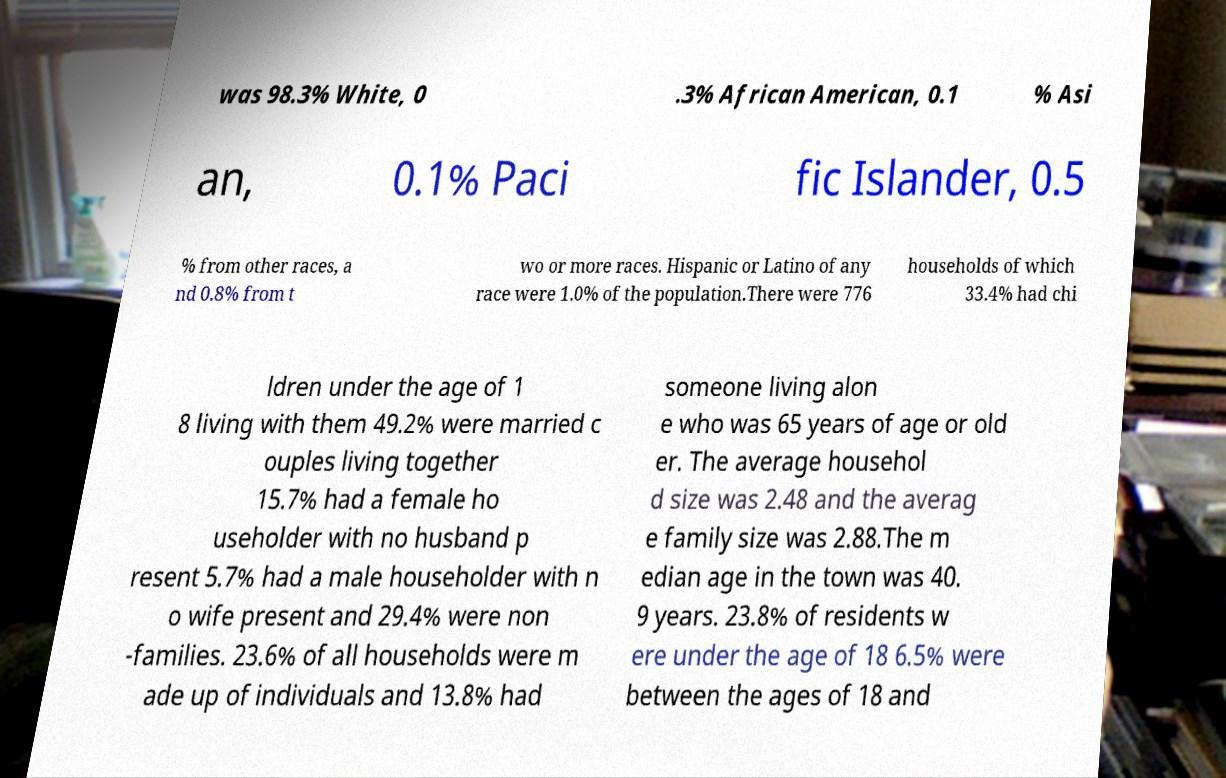I need the written content from this picture converted into text. Can you do that? was 98.3% White, 0 .3% African American, 0.1 % Asi an, 0.1% Paci fic Islander, 0.5 % from other races, a nd 0.8% from t wo or more races. Hispanic or Latino of any race were 1.0% of the population.There were 776 households of which 33.4% had chi ldren under the age of 1 8 living with them 49.2% were married c ouples living together 15.7% had a female ho useholder with no husband p resent 5.7% had a male householder with n o wife present and 29.4% were non -families. 23.6% of all households were m ade up of individuals and 13.8% had someone living alon e who was 65 years of age or old er. The average househol d size was 2.48 and the averag e family size was 2.88.The m edian age in the town was 40. 9 years. 23.8% of residents w ere under the age of 18 6.5% were between the ages of 18 and 